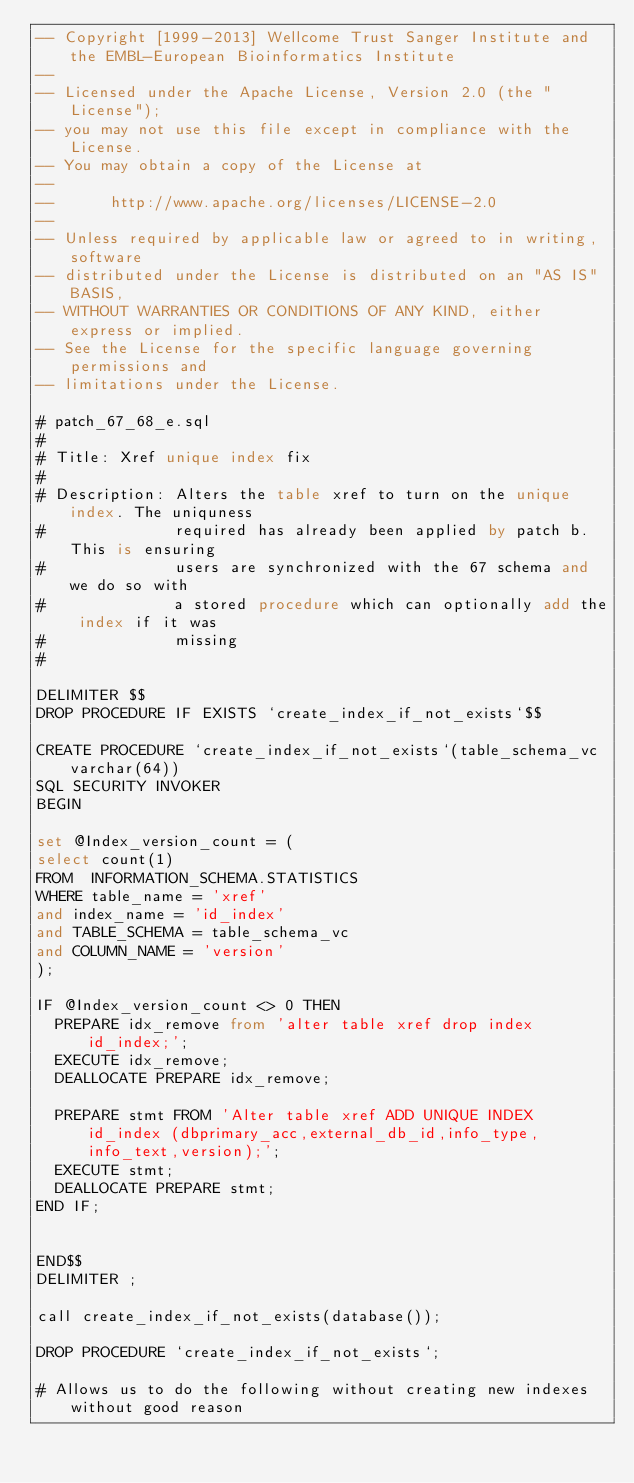<code> <loc_0><loc_0><loc_500><loc_500><_SQL_>-- Copyright [1999-2013] Wellcome Trust Sanger Institute and the EMBL-European Bioinformatics Institute
-- 
-- Licensed under the Apache License, Version 2.0 (the "License");
-- you may not use this file except in compliance with the License.
-- You may obtain a copy of the License at
-- 
--      http://www.apache.org/licenses/LICENSE-2.0
-- 
-- Unless required by applicable law or agreed to in writing, software
-- distributed under the License is distributed on an "AS IS" BASIS,
-- WITHOUT WARRANTIES OR CONDITIONS OF ANY KIND, either express or implied.
-- See the License for the specific language governing permissions and
-- limitations under the License.

# patch_67_68_e.sql
#
# Title: Xref unique index fix
#
# Description: Alters the table xref to turn on the unique index. The uniquness
#              required has already been applied by patch b. This is ensuring
#              users are synchronized with the 67 schema and we do so with
#              a stored procedure which can optionally add the index if it was 
#              missing
# 

DELIMITER $$
DROP PROCEDURE IF EXISTS `create_index_if_not_exists`$$

CREATE PROCEDURE `create_index_if_not_exists`(table_schema_vc varchar(64))
SQL SECURITY INVOKER
BEGIN

set @Index_version_count = (
select count(1)
FROM  INFORMATION_SCHEMA.STATISTICS
WHERE table_name = 'xref'
and index_name = 'id_index'
and TABLE_SCHEMA = table_schema_vc
and COLUMN_NAME = 'version'
);

IF @Index_version_count <> 0 THEN
  PREPARE idx_remove from 'alter table xref drop index id_index;';
  EXECUTE idx_remove;
  DEALLOCATE PREPARE idx_remove;
  
	PREPARE stmt FROM 'Alter table xref ADD UNIQUE INDEX id_index (dbprimary_acc,external_db_id,info_type,info_text,version);';
	EXECUTE stmt;
	DEALLOCATE PREPARE stmt;
END IF;


END$$
DELIMITER ;

call create_index_if_not_exists(database());

DROP PROCEDURE `create_index_if_not_exists`;

# Allows us to do the following without creating new indexes without good reason</code> 